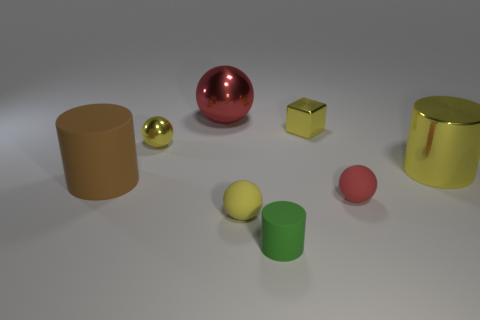There is a red object that is in front of the big rubber thing; is it the same shape as the big object that is right of the small yellow metallic cube?
Your response must be concise. No. There is a large cylinder right of the large thing in front of the large yellow metal thing; how many matte cylinders are behind it?
Provide a short and direct response. 0. The metallic block has what color?
Ensure brevity in your answer.  Yellow. How many other things are there of the same size as the green cylinder?
Your answer should be very brief. 4. What is the material of the yellow object that is the same shape as the green thing?
Ensure brevity in your answer.  Metal. The small yellow object in front of the rubber thing that is to the left of the tiny yellow sphere that is behind the large rubber object is made of what material?
Ensure brevity in your answer.  Rubber. There is a yellow ball that is made of the same material as the small yellow block; what size is it?
Keep it short and to the point. Small. Is there anything else that has the same color as the small metallic sphere?
Provide a succinct answer. Yes. Does the cylinder to the left of the large red shiny sphere have the same color as the big cylinder that is on the right side of the large brown rubber thing?
Your response must be concise. No. What color is the large cylinder that is behind the brown matte cylinder?
Offer a terse response. Yellow. 